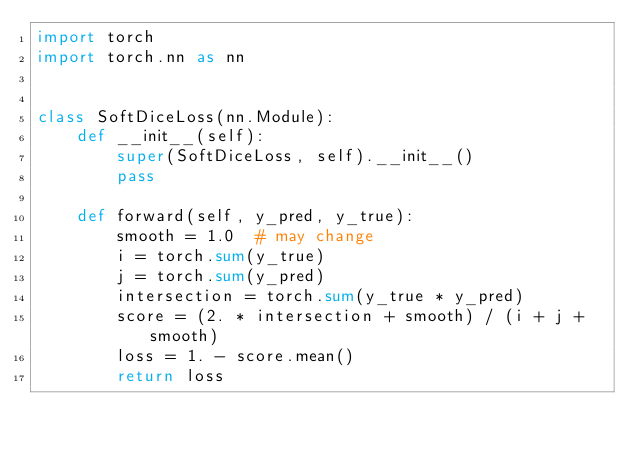Convert code to text. <code><loc_0><loc_0><loc_500><loc_500><_Python_>import torch
import torch.nn as nn


class SoftDiceLoss(nn.Module):
    def __init__(self):
        super(SoftDiceLoss, self).__init__()
        pass

    def forward(self, y_pred, y_true):
        smooth = 1.0  # may change
        i = torch.sum(y_true)
        j = torch.sum(y_pred)
        intersection = torch.sum(y_true * y_pred)
        score = (2. * intersection + smooth) / (i + j + smooth)
        loss = 1. - score.mean()
        return loss
</code> 